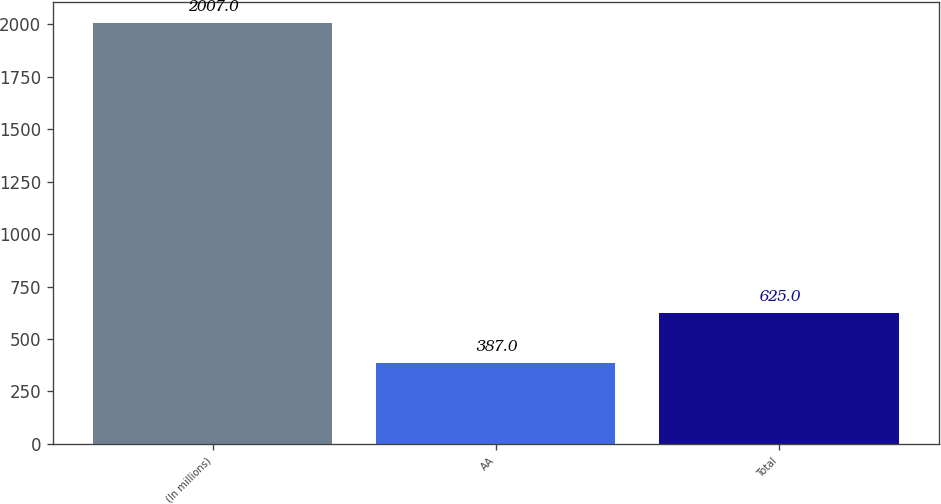Convert chart. <chart><loc_0><loc_0><loc_500><loc_500><bar_chart><fcel>(In millions)<fcel>AA<fcel>Total<nl><fcel>2007<fcel>387<fcel>625<nl></chart> 